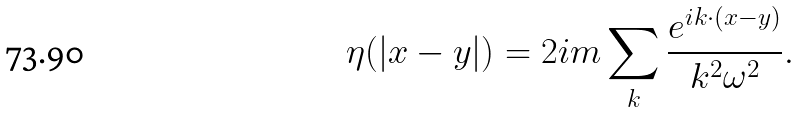Convert formula to latex. <formula><loc_0><loc_0><loc_500><loc_500>\eta ( | { x - y } | ) = 2 i m \sum _ { k } { \frac { e ^ { i { k \cdot ( x - y ) } } } { k ^ { 2 } \omega ^ { 2 } } } .</formula> 